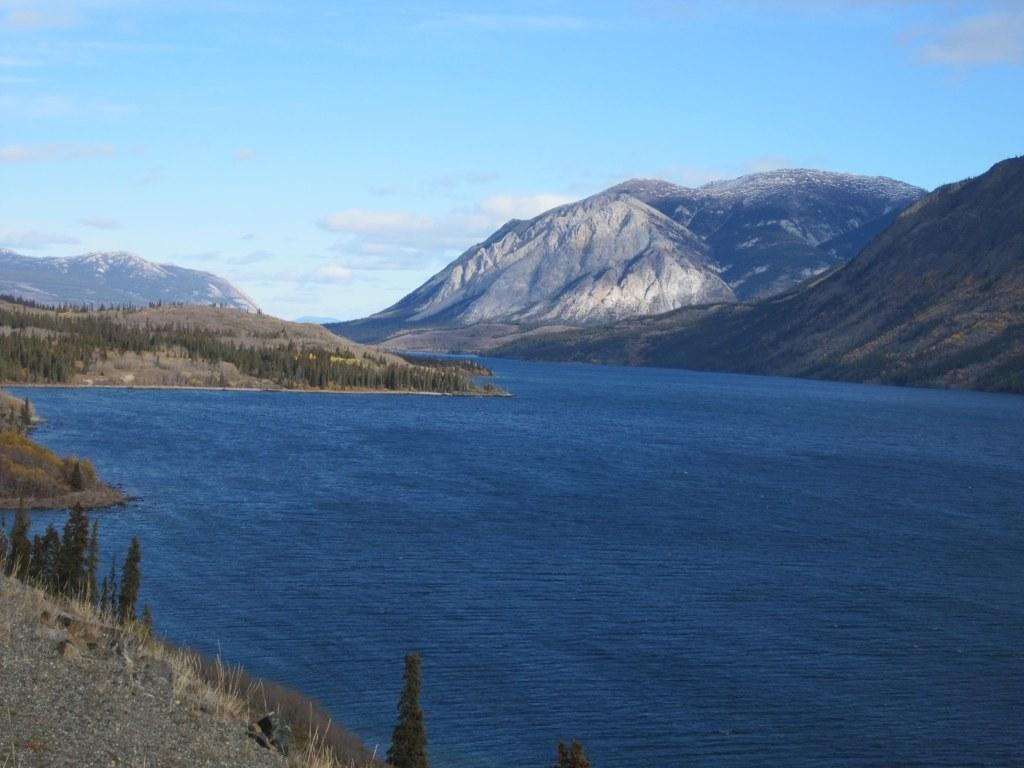What is the primary element visible in the image? There is water in the image. What type of natural formation can be seen on the right side of the image? There are mountains on the right side of the image. What type of vegetation is visible in the image? There are plants visible in the image. What color is the sky at the top of the image? The sky is blue at the top of the image. Who is the creator of the scarf seen in the image? There is no scarf present in the image. How does the wind affect the plants in the image? There is no mention of wind in the image, so its effect on the plants cannot be determined. 